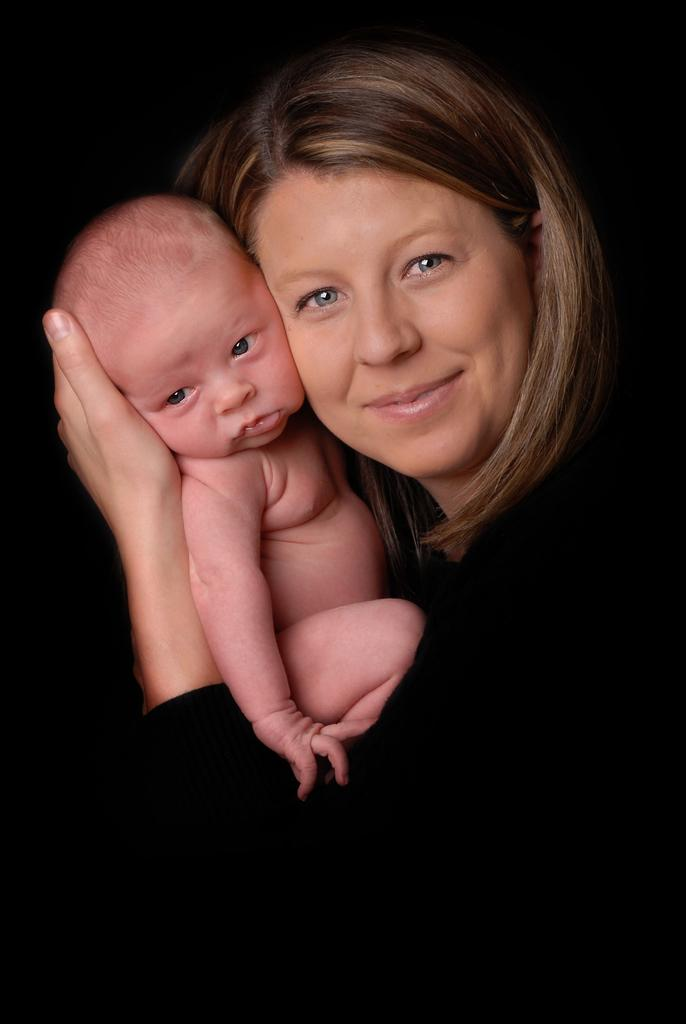What is the main subject of the image? The main subject of the image is a woman. What is the woman doing in the image? The woman is holding a kid in the image. What is the woman wearing in the image? The woman is wearing a black dress in the image. What type of leather material is being used by the woman to perform division in the image? There is no leather material or division being performed in the image. The woman is simply holding a kid while wearing a black dress. 